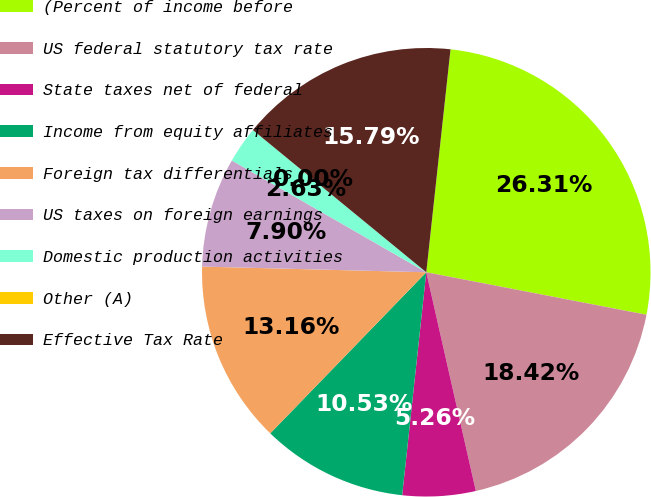<chart> <loc_0><loc_0><loc_500><loc_500><pie_chart><fcel>(Percent of income before<fcel>US federal statutory tax rate<fcel>State taxes net of federal<fcel>Income from equity affiliates<fcel>Foreign tax differentials<fcel>US taxes on foreign earnings<fcel>Domestic production activities<fcel>Other (A)<fcel>Effective Tax Rate<nl><fcel>26.31%<fcel>18.42%<fcel>5.26%<fcel>10.53%<fcel>13.16%<fcel>7.9%<fcel>2.63%<fcel>0.0%<fcel>15.79%<nl></chart> 